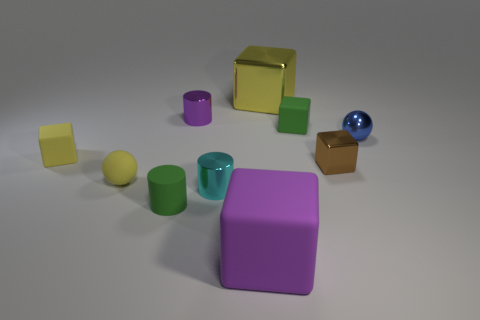How many things are either small green things that are behind the matte cylinder or small things on the right side of the large purple rubber cube?
Offer a very short reply. 3. Is there a tiny yellow matte thing of the same shape as the purple shiny object?
Offer a very short reply. No. There is a thing that is the same color as the small matte cylinder; what is it made of?
Offer a terse response. Rubber. What number of metal objects are either big purple blocks or small yellow balls?
Your answer should be very brief. 0. What is the shape of the small cyan shiny object?
Your answer should be very brief. Cylinder. How many blue objects are the same material as the small cyan thing?
Offer a very short reply. 1. What is the color of the large object that is made of the same material as the tiny brown thing?
Your answer should be compact. Yellow. There is a purple thing in front of the purple cylinder; is its size the same as the small green cylinder?
Give a very brief answer. No. The other large object that is the same shape as the big yellow thing is what color?
Make the answer very short. Purple. What shape is the yellow object that is behind the yellow matte object that is behind the small sphere on the left side of the green matte cylinder?
Ensure brevity in your answer.  Cube. 